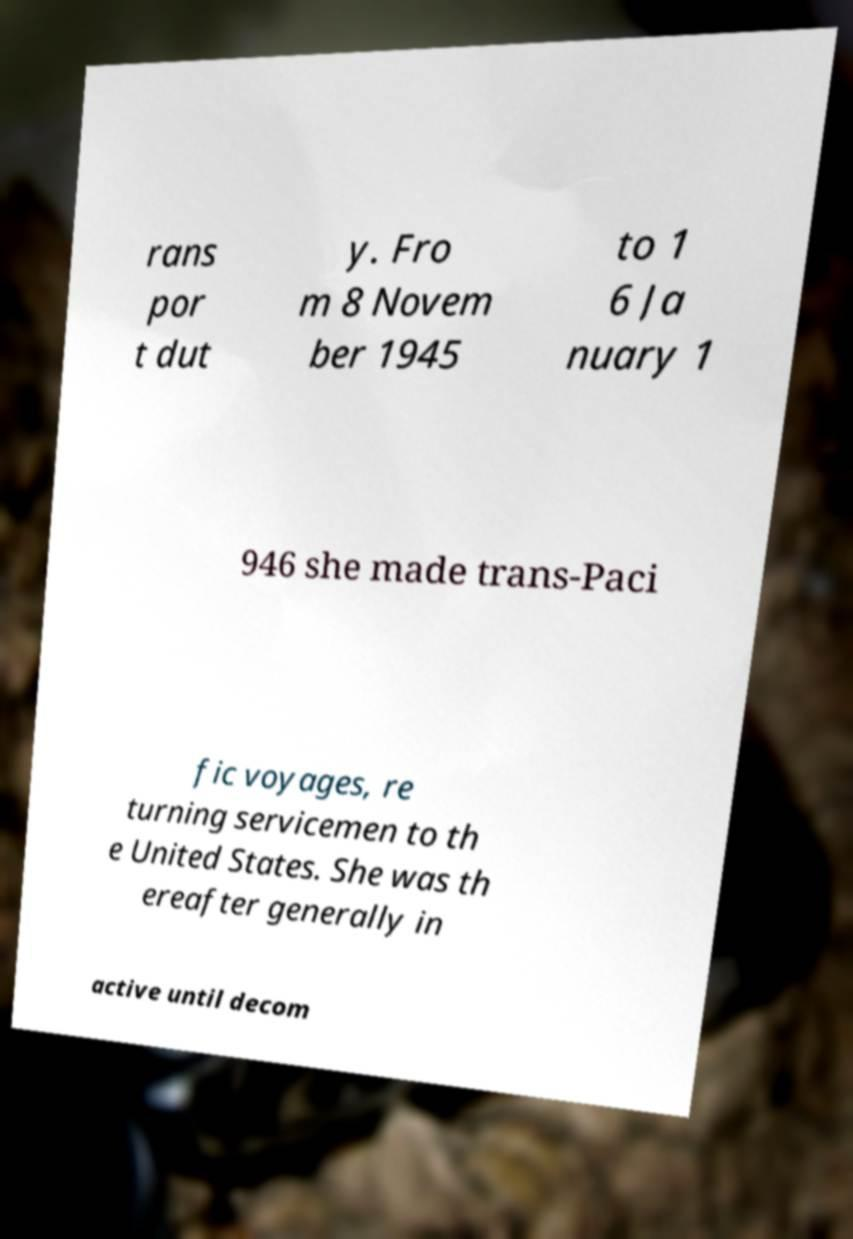Please read and relay the text visible in this image. What does it say? rans por t dut y. Fro m 8 Novem ber 1945 to 1 6 Ja nuary 1 946 she made trans-Paci fic voyages, re turning servicemen to th e United States. She was th ereafter generally in active until decom 